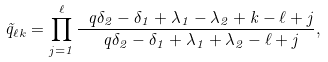Convert formula to latex. <formula><loc_0><loc_0><loc_500><loc_500>\tilde { q } _ { \ell k } = \prod _ { j = 1 } ^ { \ell } \frac { \ q { \delta _ { 2 } - \delta _ { 1 } + \lambda _ { 1 } - \lambda _ { 2 } + k - \ell + j } } { \ q { \delta _ { 2 } - \delta _ { 1 } + \lambda _ { 1 } + \lambda _ { 2 } - \ell + j } } ,</formula> 